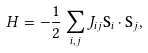Convert formula to latex. <formula><loc_0><loc_0><loc_500><loc_500>H = - \frac { 1 } { 2 } \sum _ { i , j } J _ { i j } \mathbf S _ { i } \cdot \mathbf S _ { j } ,</formula> 